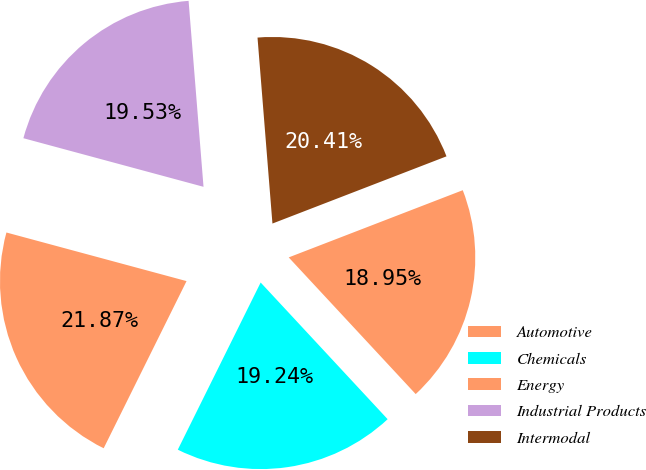<chart> <loc_0><loc_0><loc_500><loc_500><pie_chart><fcel>Automotive<fcel>Chemicals<fcel>Energy<fcel>Industrial Products<fcel>Intermodal<nl><fcel>18.95%<fcel>19.24%<fcel>21.87%<fcel>19.53%<fcel>20.41%<nl></chart> 